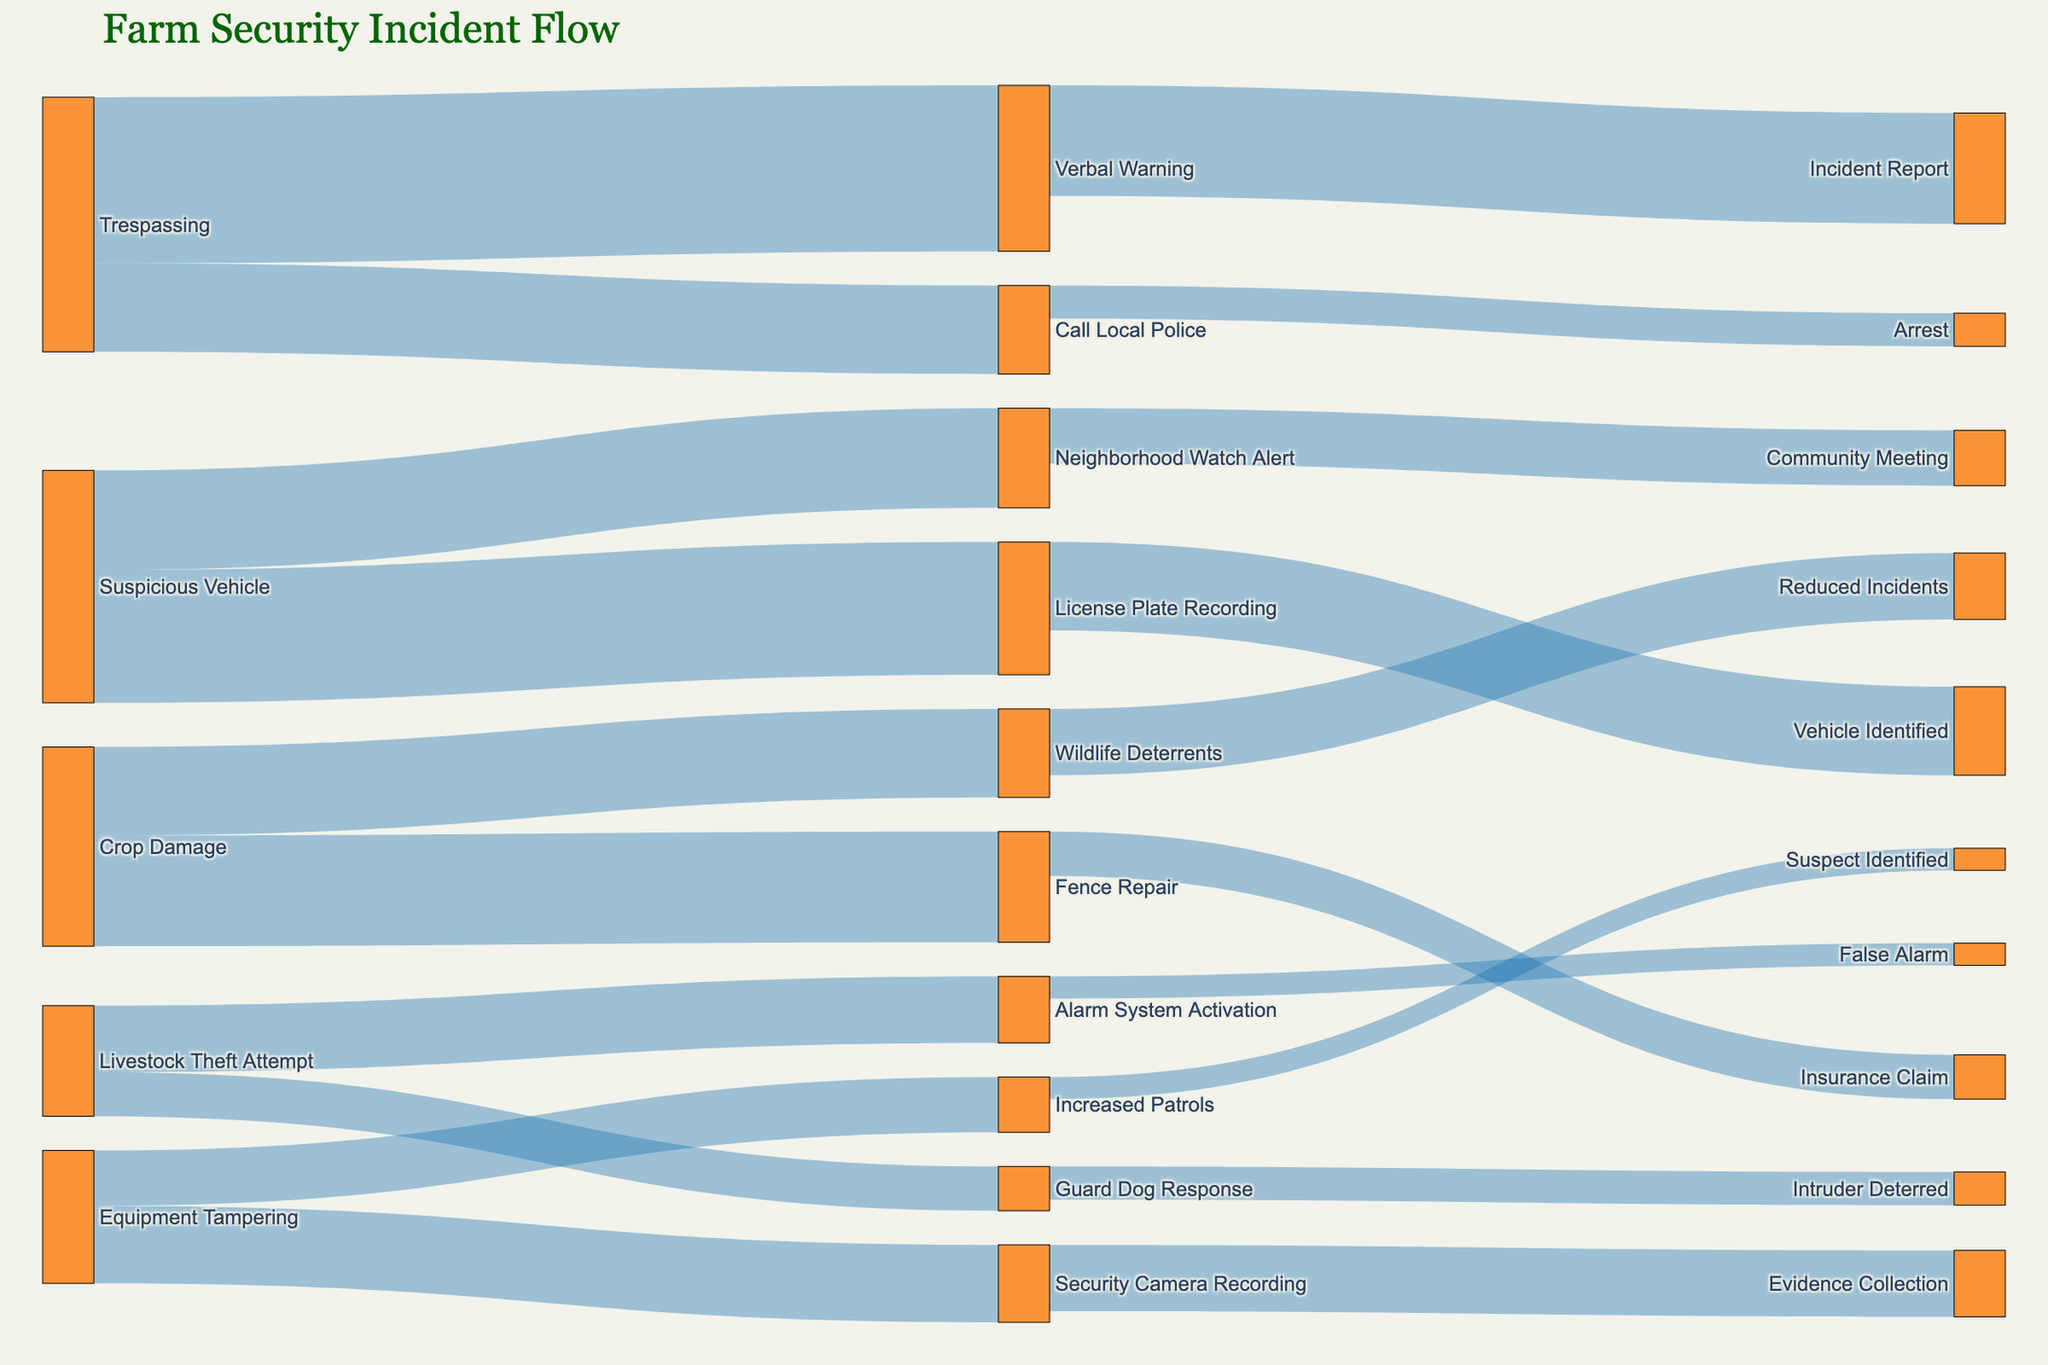How many security incidents resulted in a verbal warning? Identify the links connecting 'Trespassing' to 'Verbal Warning' and sum the values. The link showing 'Trespassing' to 'Verbal Warning' has a value of 15.
Answer: 15 What is the total number of incidents for crop damage? Find all target links originating from 'Crop Damage' and sum their values: 'Crop Damage' to 'Fence Repair' (10) and 'Crop Damage' to 'Wildlife Deterrents' (8). The total is 10 + 8 = 18.
Answer: 18 Which response measure was used more for suspicious vehicles: 'License Plate Recording' or 'Neighborhood Watch Alert'? Compare the values of the links connected to 'Suspicious Vehicle': 'License Plate Recording' (12) and 'Neighborhood Watch Alert' (9). 'License Plate Recording' has a higher value.
Answer: License Plate Recording How frequently did increased patrols result in suspect identification? Find the link going from 'Increased Patrols' to 'Suspect Identified,' which has a value of 2.
Answer: 2 What is the combined value of incidents where equipment tampering resulted in security camera recording and increased patrols? Sum the values of the links 'Equipment Tampering' to 'Security Camera Recording' (7) and 'Equipment Tampering' to 'Increased Patrols' (5). The total is 7 + 5 = 12.
Answer: 12 How many incidents led to an insurance claim? Find the link showing 'Fence Repair' leading to 'Insurance Claim,' which has a value of 4.
Answer: 4 What's the difference between the number of wildlife deterrents set up and fence repairs done in response to crop damage? Compare the values for 'Crop Damage' leading to 'Wildlife Deterrents' (8) and 'Crop Damage' to 'Fence Repair' (10). The difference is 10 - 8 = 2.
Answer: 2 Which incident type resulted in the least alarm system activations? 'Livestock Theft Attempt' is the only incident type leading to 'Alarm System Activation' (6). Considering no other incident types triggered the alarm system, the least activation remains 6.
Answer: 6 What happened to most entries labeled as 'Call Local Police'? Look at the link from 'Call Local Police' to 'Arrest,' which has a value of 3 compared to 'Call Local Police,' which has a value of 8. Summarizing visually, it shows most instances end rather inconclusively.
Answer: Arrest How many total items were recorded through security cameras? Sum values for 'Security Camera Recording' leading to 'Evidence Collection' (6).
Answer: 6 